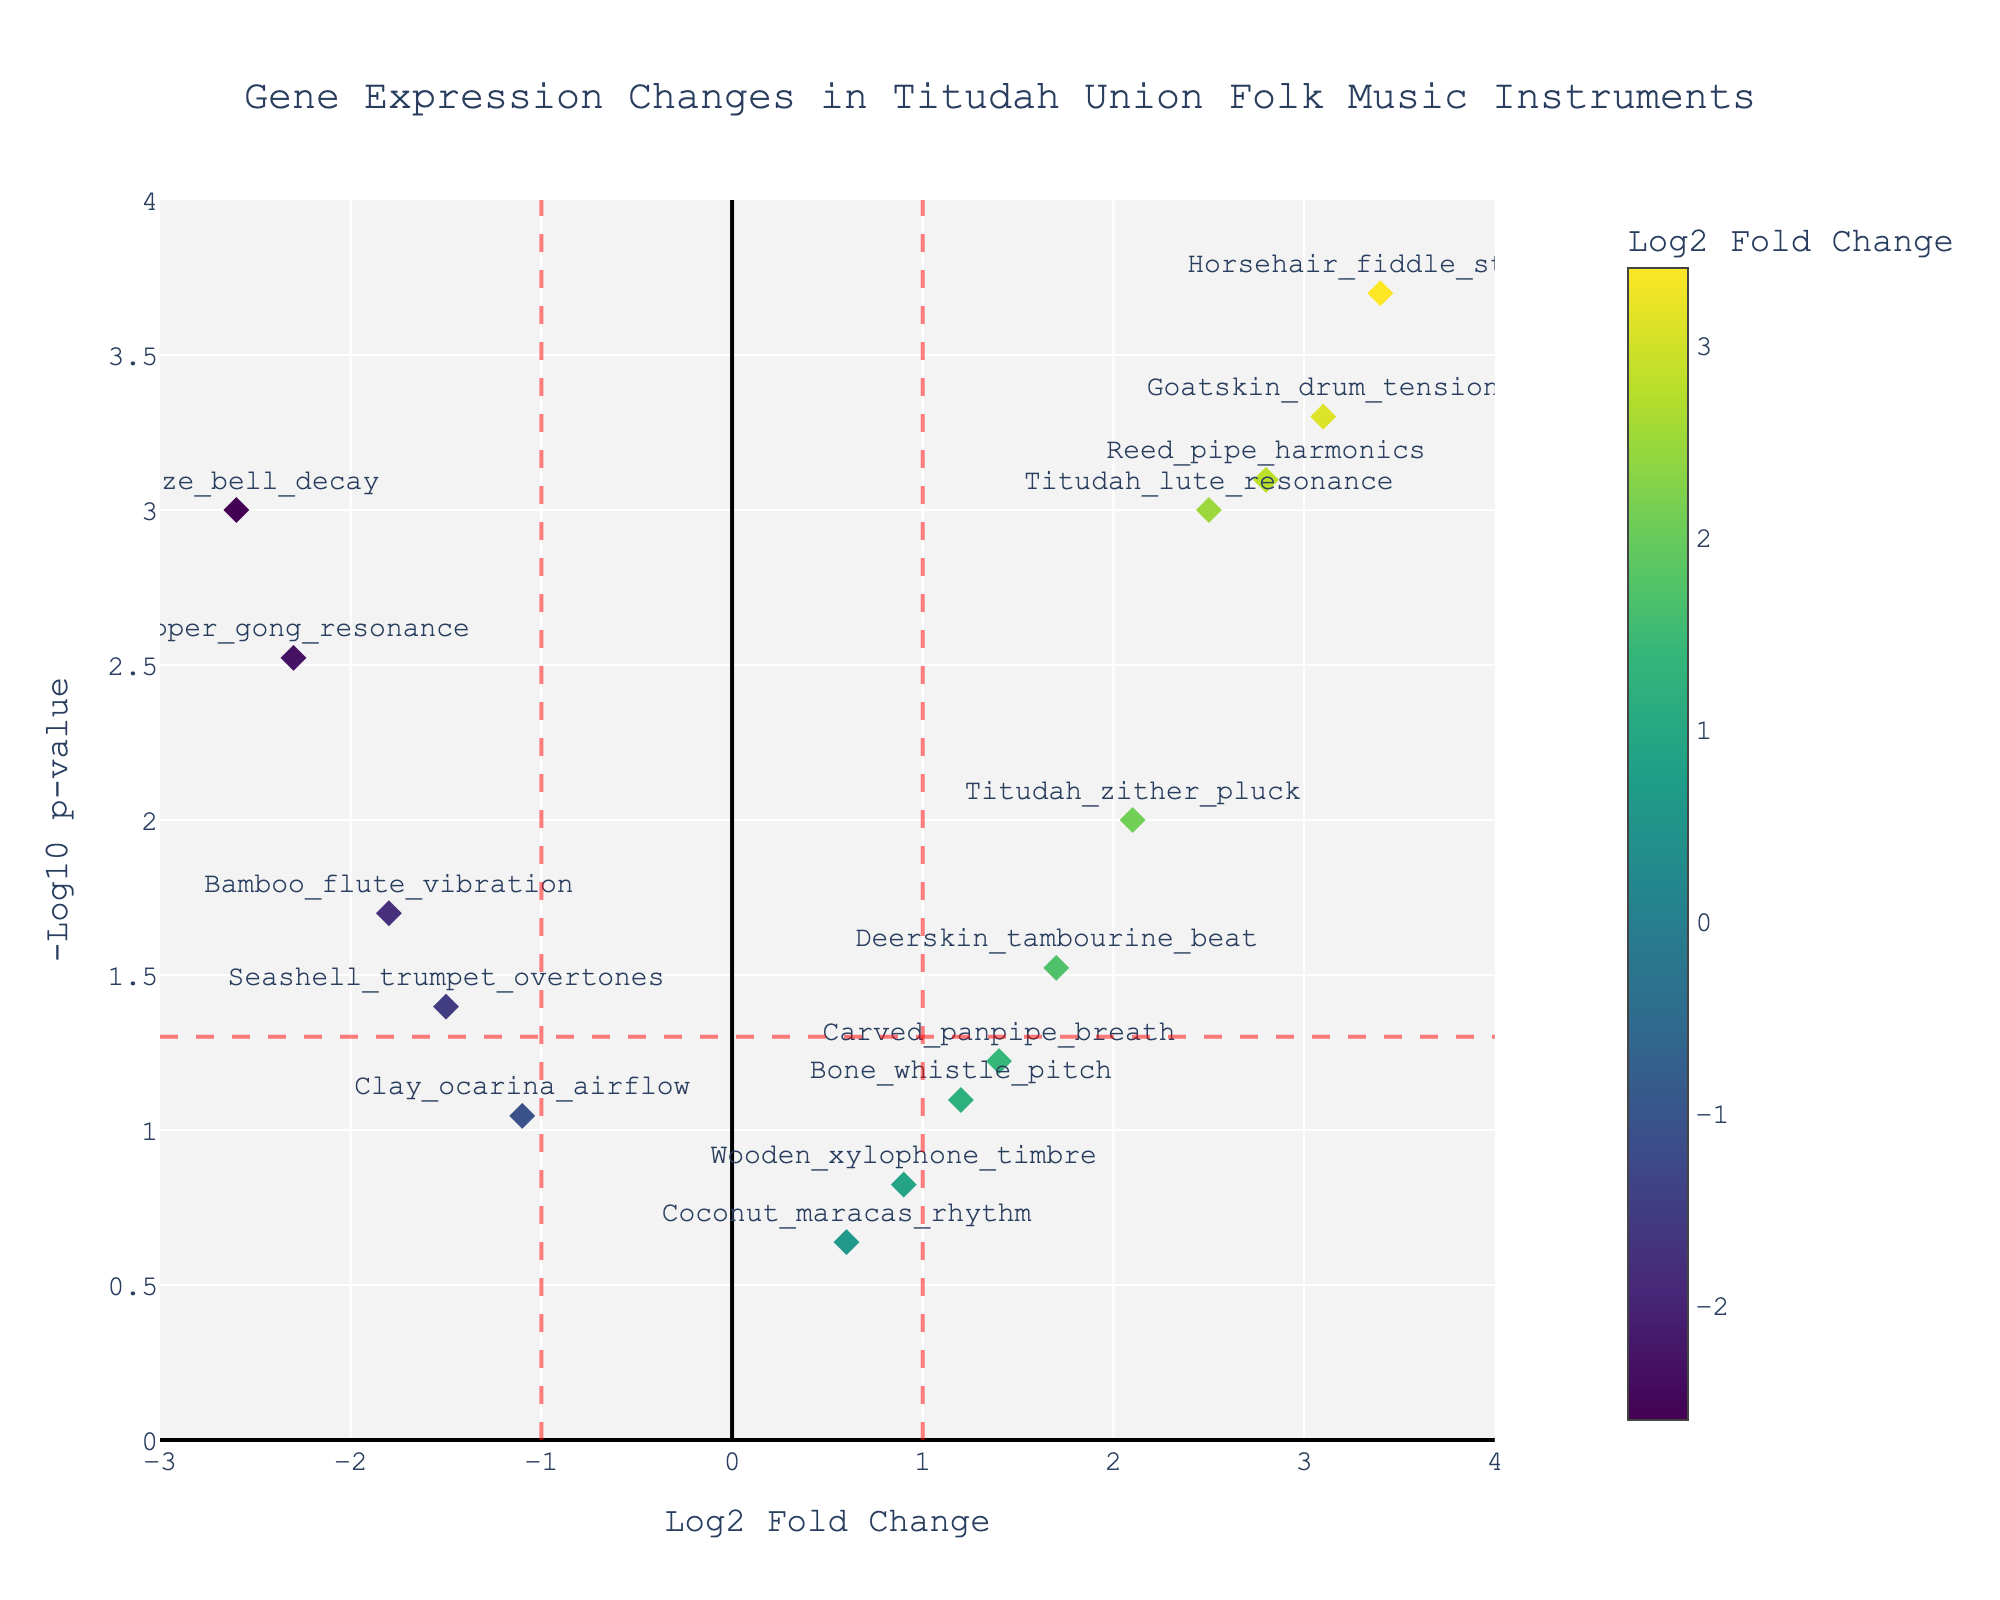What is the title of the plot? The title is usually located at the top of the figure and specifies the theme or topic of the graph. Here, it states "Gene Expression Changes in Titudah Union Folk Music Instruments."
Answer: Gene Expression Changes in Titudah Union Folk Music Instruments How many data points have a log2 fold change greater than 2? Identify all points on the x-axis where the log2 fold change is greater than 2. These are points to the right of the line at x=2.
Answer: 5 Which data point has the smallest p-value? The p-value is visually represented by the highest position on the y-axis (-log10(p-value)). Identify the highest data point on the plot.
Answer: Horsehair_fiddle_string What are the values of log2 fold change and p-value for Bamboo_flute_vibration? Locate the Bamboo_flute_vibration label on the plot and read the corresponding x (log2 fold change) and y (-log10(p-value)) values. Convert -log10(p-value) back to p-value if necessary.
Answer: Log2 fold change: -1.8, p-value: 0.02 Which instruments have a significant positive change in gene expression (log2 fold change > 1 and p-value < 0.05)? Points satisfying log2 fold change > 1 are to the right of the red vertical line at x=1. Points satisfying p-value < 0.05 are above the red horizontal line. Look for points satisfying both conditions.
Answer: Titudah_lute_resonance, Goatskin_drum_tension, Reed_pipe_harmonics, Horsehair_fiddle_string, Titudah_zither_pluck How many data points are significantly expressed (p-value < 0.05)? Count all the data points above the red horizontal line representing -log10(0.05).
Answer: 8 Which instrument shows the greatest negative log2 fold change? Find the data point furthest to the left on the x-axis (most negative log2 fold change value).
Answer: Bronze_bell_decay Compare Titudah_zither_pluck and Carved_panpipe_breath. Which one has a more significant p-value? Check the positions of both points on the y-axis. The higher the point, the lower its p-value (more significant).
Answer: Titudah_zither_pluck What is the range of log2 fold changes presented in the plot? Inspect the x-axis and identify the minimum and maximum values represented. The range is the difference between these two values.
Answer: -2.6 to 3.4 